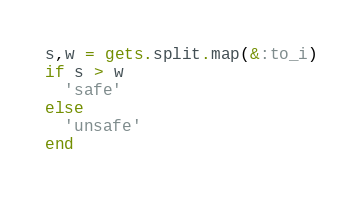<code> <loc_0><loc_0><loc_500><loc_500><_Ruby_>s,w = gets.split.map(&:to_i)
if s > w
  'safe'
else
  'unsafe'
end</code> 